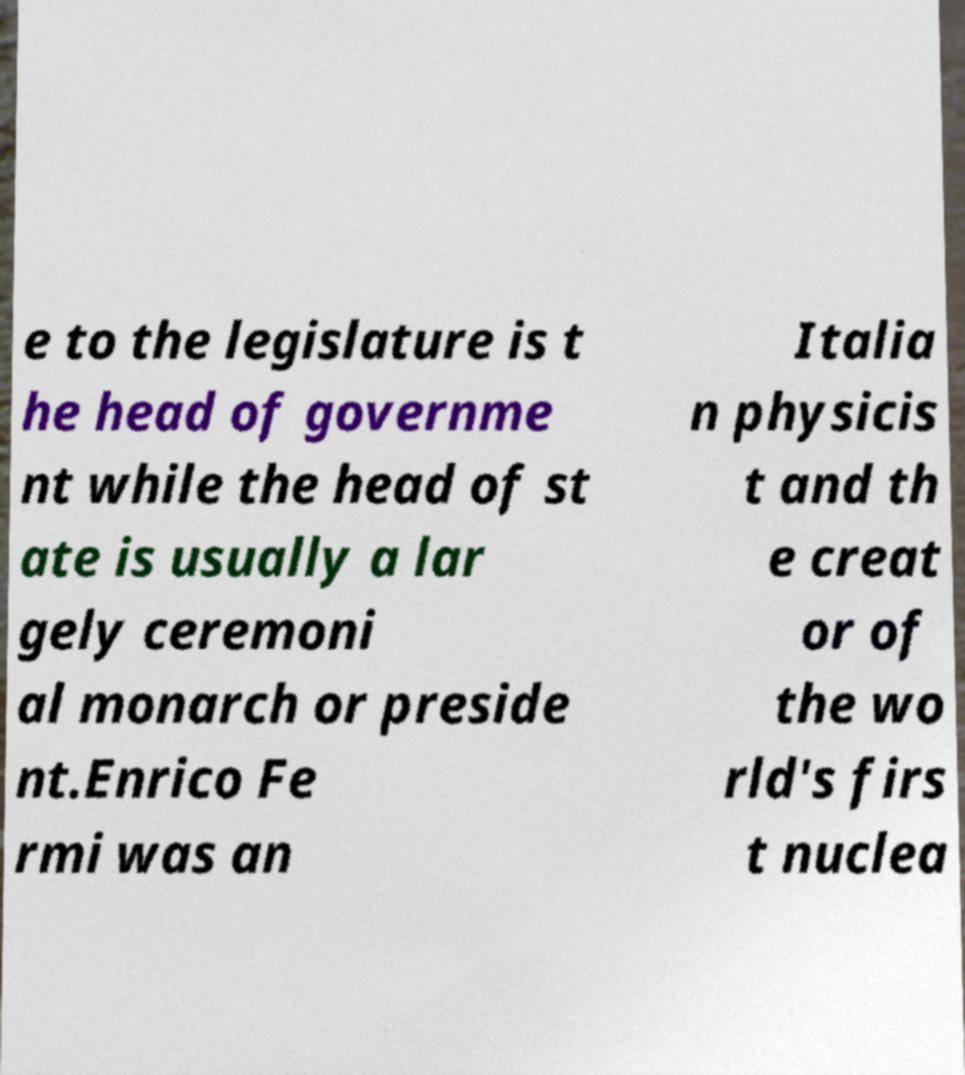There's text embedded in this image that I need extracted. Can you transcribe it verbatim? e to the legislature is t he head of governme nt while the head of st ate is usually a lar gely ceremoni al monarch or preside nt.Enrico Fe rmi was an Italia n physicis t and th e creat or of the wo rld's firs t nuclea 